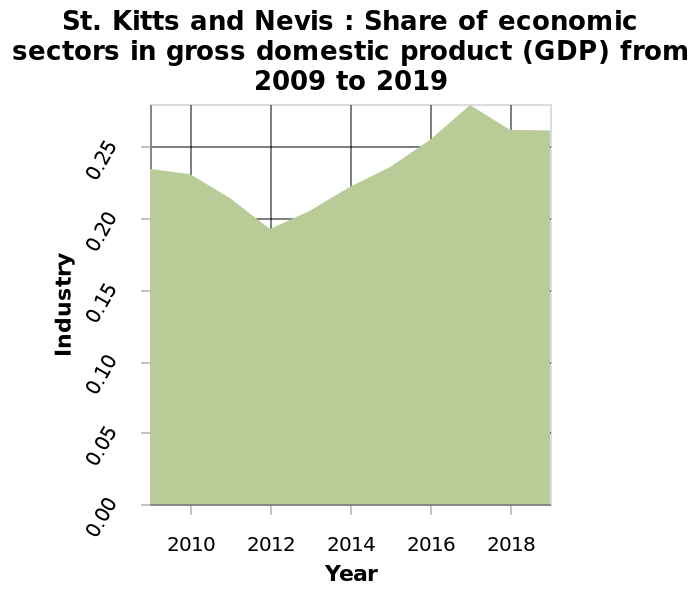<image>
How much did the market share decrease to in 2012?  The market share decreased to just below 0.20 in 2012. Offer a thorough analysis of the image. In 2010, they had just below 0.25 share which later decreased in 2012 to bottom just below 0.20. This then steadily increased over the years after 2012, finding an all time high in 2017 of 0.30. 